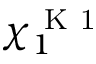<formula> <loc_0><loc_0><loc_500><loc_500>\chi _ { 1 } ^ { K 1 }</formula> 